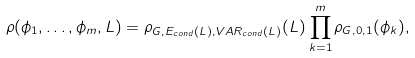Convert formula to latex. <formula><loc_0><loc_0><loc_500><loc_500>\rho ( \phi _ { 1 } , \dots , \phi _ { m } , L ) = \rho _ { G , E _ { c o n d } ( L ) , V A R _ { c o n d } ( L ) } ( L ) \prod _ { k = 1 } ^ { m } \rho _ { G , 0 , 1 } ( \phi _ { k } ) ,</formula> 